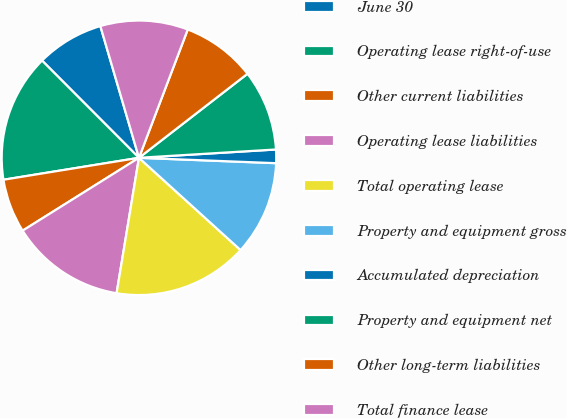<chart> <loc_0><loc_0><loc_500><loc_500><pie_chart><fcel>June 30<fcel>Operating lease right-of-use<fcel>Other current liabilities<fcel>Operating lease liabilities<fcel>Total operating lease<fcel>Property and equipment gross<fcel>Accumulated depreciation<fcel>Property and equipment net<fcel>Other long-term liabilities<fcel>Total finance lease<nl><fcel>7.94%<fcel>15.08%<fcel>6.35%<fcel>13.49%<fcel>15.87%<fcel>11.11%<fcel>1.59%<fcel>9.52%<fcel>8.73%<fcel>10.32%<nl></chart> 